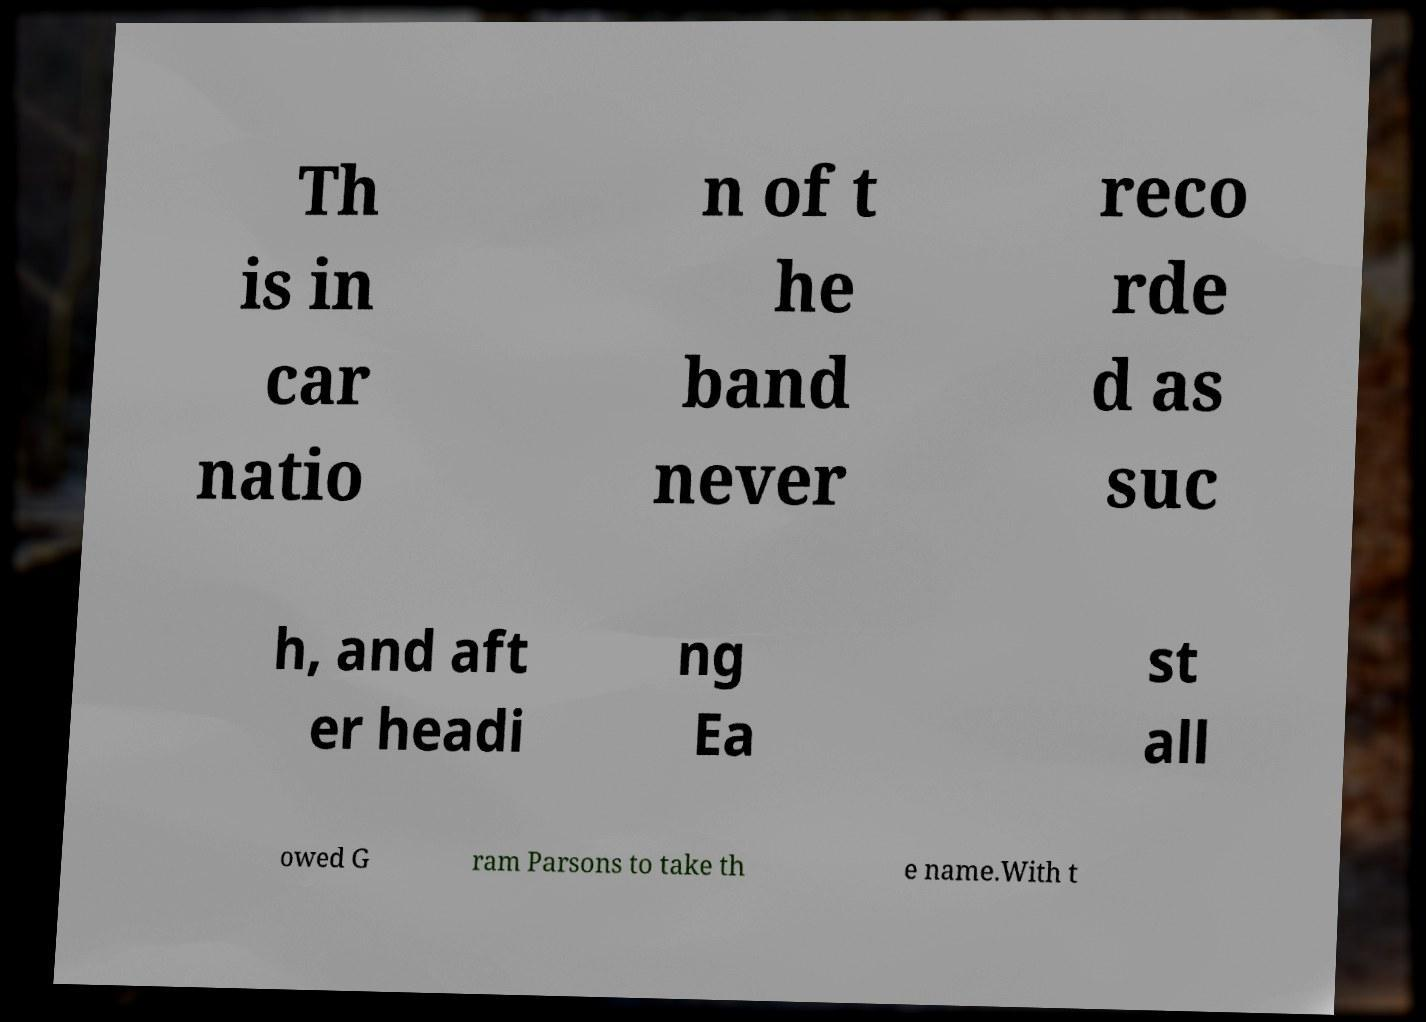Can you read and provide the text displayed in the image?This photo seems to have some interesting text. Can you extract and type it out for me? Th is in car natio n of t he band never reco rde d as suc h, and aft er headi ng Ea st all owed G ram Parsons to take th e name.With t 